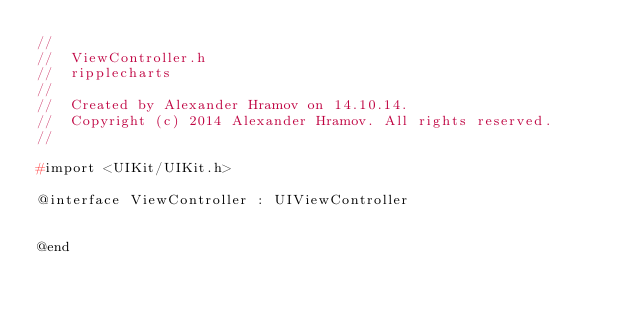Convert code to text. <code><loc_0><loc_0><loc_500><loc_500><_C_>//
//  ViewController.h
//  ripplecharts
//
//  Created by Alexander Hramov on 14.10.14.
//  Copyright (c) 2014 Alexander Hramov. All rights reserved.
//

#import <UIKit/UIKit.h>

@interface ViewController : UIViewController


@end

</code> 